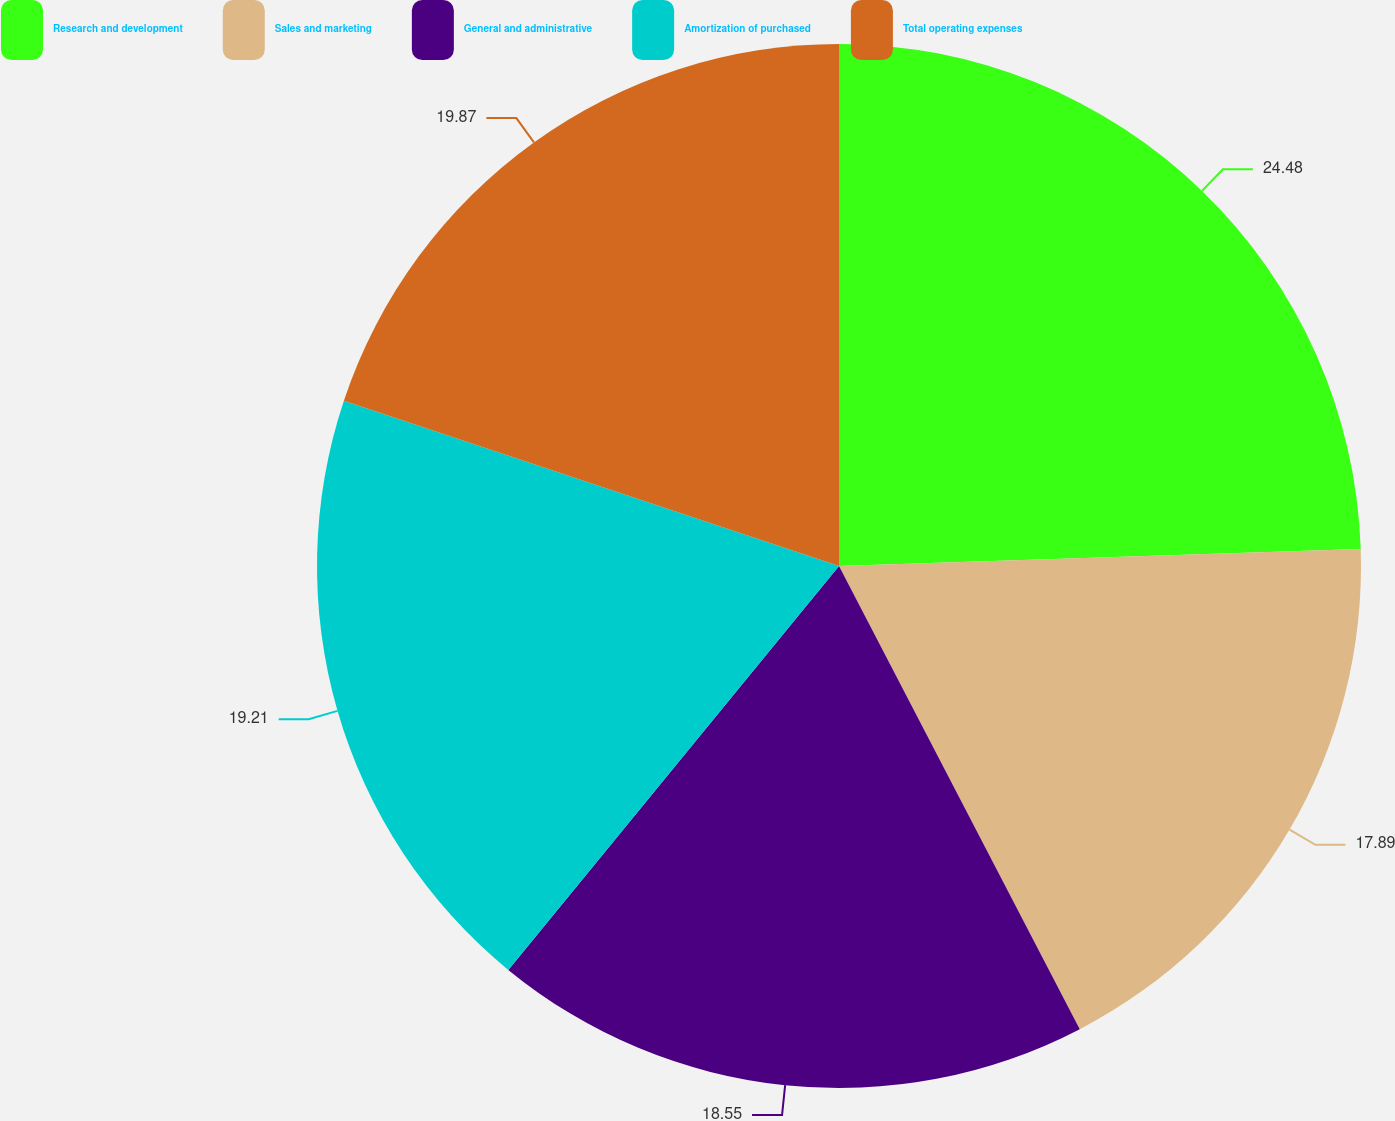Convert chart. <chart><loc_0><loc_0><loc_500><loc_500><pie_chart><fcel>Research and development<fcel>Sales and marketing<fcel>General and administrative<fcel>Amortization of purchased<fcel>Total operating expenses<nl><fcel>24.48%<fcel>17.89%<fcel>18.55%<fcel>19.21%<fcel>19.87%<nl></chart> 